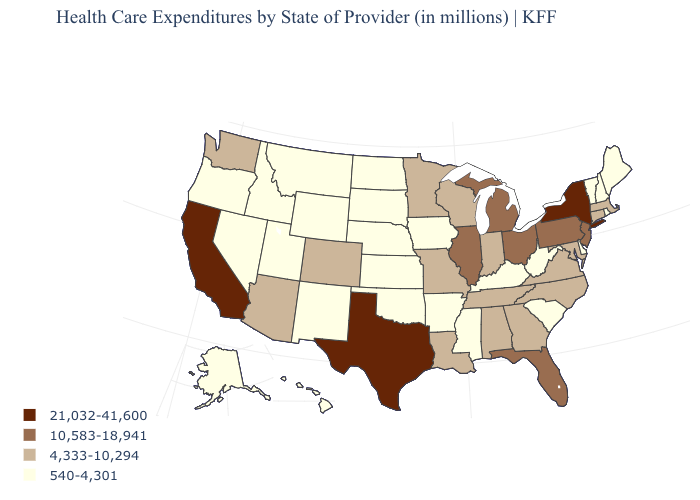What is the highest value in the USA?
Write a very short answer. 21,032-41,600. What is the value of Texas?
Answer briefly. 21,032-41,600. Does Utah have a lower value than Washington?
Quick response, please. Yes. Which states have the lowest value in the South?
Short answer required. Arkansas, Delaware, Kentucky, Mississippi, Oklahoma, South Carolina, West Virginia. What is the value of Maine?
Keep it brief. 540-4,301. How many symbols are there in the legend?
Give a very brief answer. 4. Name the states that have a value in the range 4,333-10,294?
Write a very short answer. Alabama, Arizona, Colorado, Connecticut, Georgia, Indiana, Louisiana, Maryland, Massachusetts, Minnesota, Missouri, North Carolina, Tennessee, Virginia, Washington, Wisconsin. Name the states that have a value in the range 540-4,301?
Write a very short answer. Alaska, Arkansas, Delaware, Hawaii, Idaho, Iowa, Kansas, Kentucky, Maine, Mississippi, Montana, Nebraska, Nevada, New Hampshire, New Mexico, North Dakota, Oklahoma, Oregon, Rhode Island, South Carolina, South Dakota, Utah, Vermont, West Virginia, Wyoming. Which states have the lowest value in the USA?
Give a very brief answer. Alaska, Arkansas, Delaware, Hawaii, Idaho, Iowa, Kansas, Kentucky, Maine, Mississippi, Montana, Nebraska, Nevada, New Hampshire, New Mexico, North Dakota, Oklahoma, Oregon, Rhode Island, South Carolina, South Dakota, Utah, Vermont, West Virginia, Wyoming. Name the states that have a value in the range 10,583-18,941?
Quick response, please. Florida, Illinois, Michigan, New Jersey, Ohio, Pennsylvania. Name the states that have a value in the range 4,333-10,294?
Be succinct. Alabama, Arizona, Colorado, Connecticut, Georgia, Indiana, Louisiana, Maryland, Massachusetts, Minnesota, Missouri, North Carolina, Tennessee, Virginia, Washington, Wisconsin. What is the value of Louisiana?
Concise answer only. 4,333-10,294. Does Maine have a lower value than Minnesota?
Short answer required. Yes. Among the states that border New Hampshire , which have the highest value?
Give a very brief answer. Massachusetts. Does New York have the highest value in the USA?
Answer briefly. Yes. 